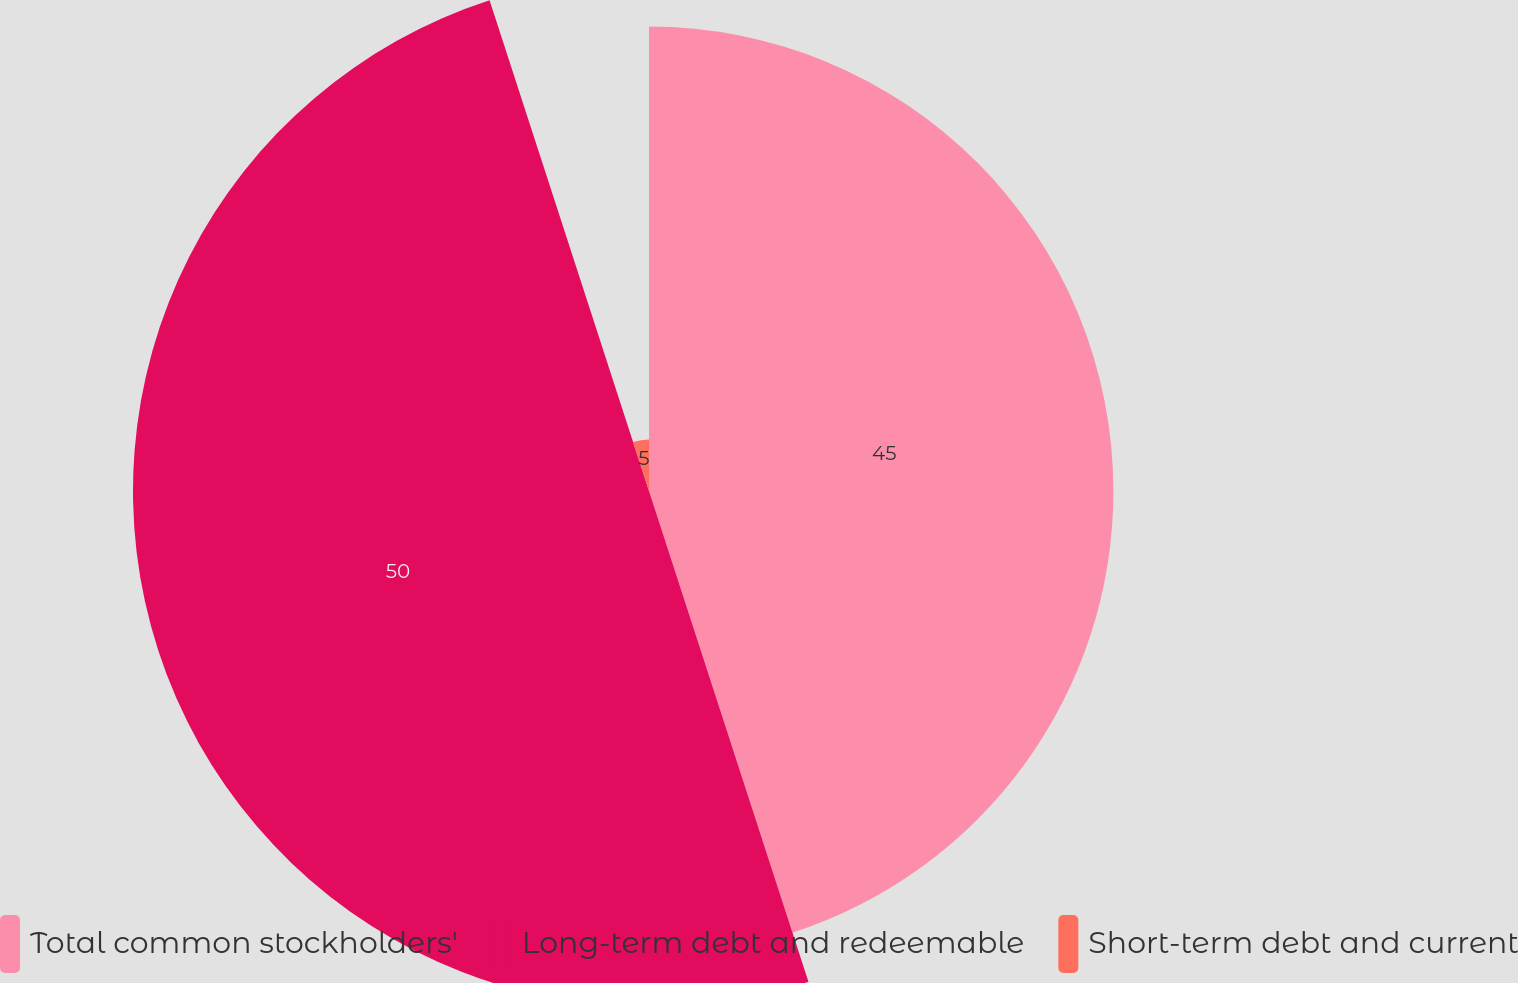<chart> <loc_0><loc_0><loc_500><loc_500><pie_chart><fcel>Total common stockholders'<fcel>Long-term debt and redeemable<fcel>Short-term debt and current<nl><fcel>45.0%<fcel>50.0%<fcel>5.0%<nl></chart> 